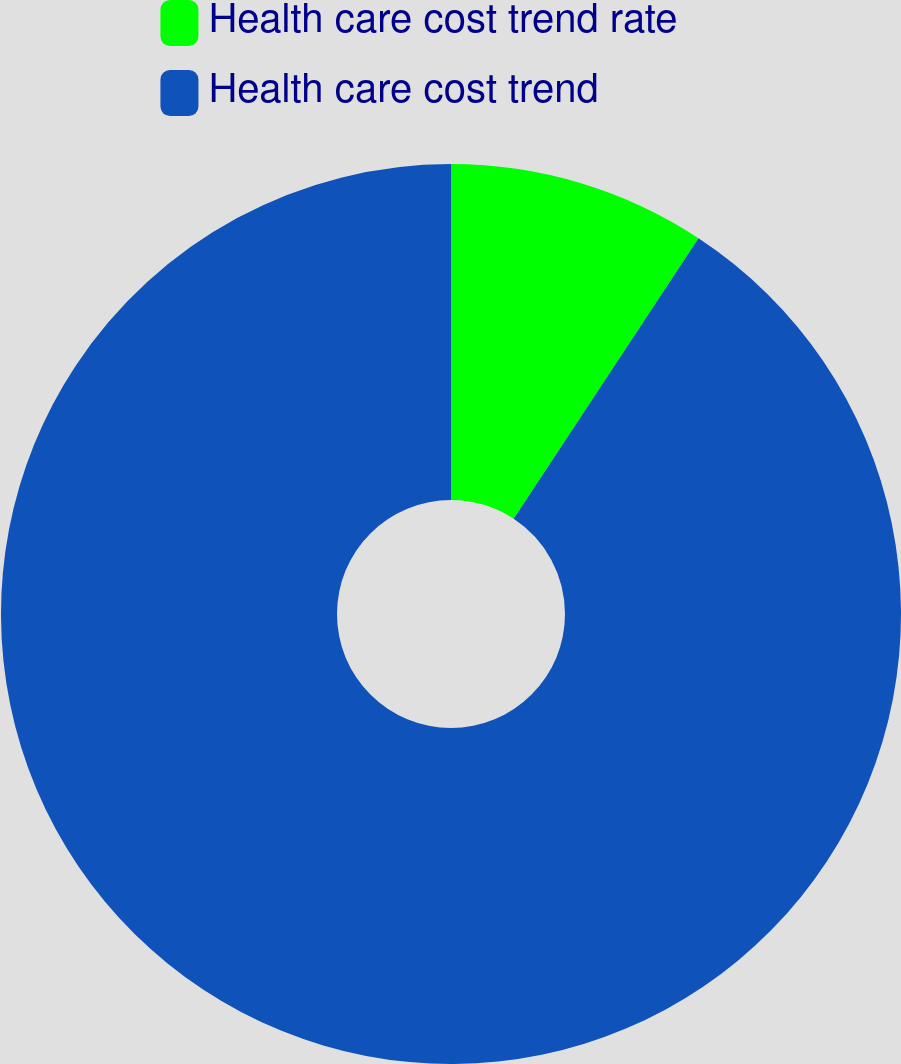<chart> <loc_0><loc_0><loc_500><loc_500><pie_chart><fcel>Health care cost trend rate<fcel>Health care cost trend<nl><fcel>9.27%<fcel>90.73%<nl></chart> 